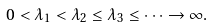Convert formula to latex. <formula><loc_0><loc_0><loc_500><loc_500>0 < \lambda _ { 1 } < \lambda _ { 2 } \leq \lambda _ { 3 } \leq \dots \to \infty .</formula> 